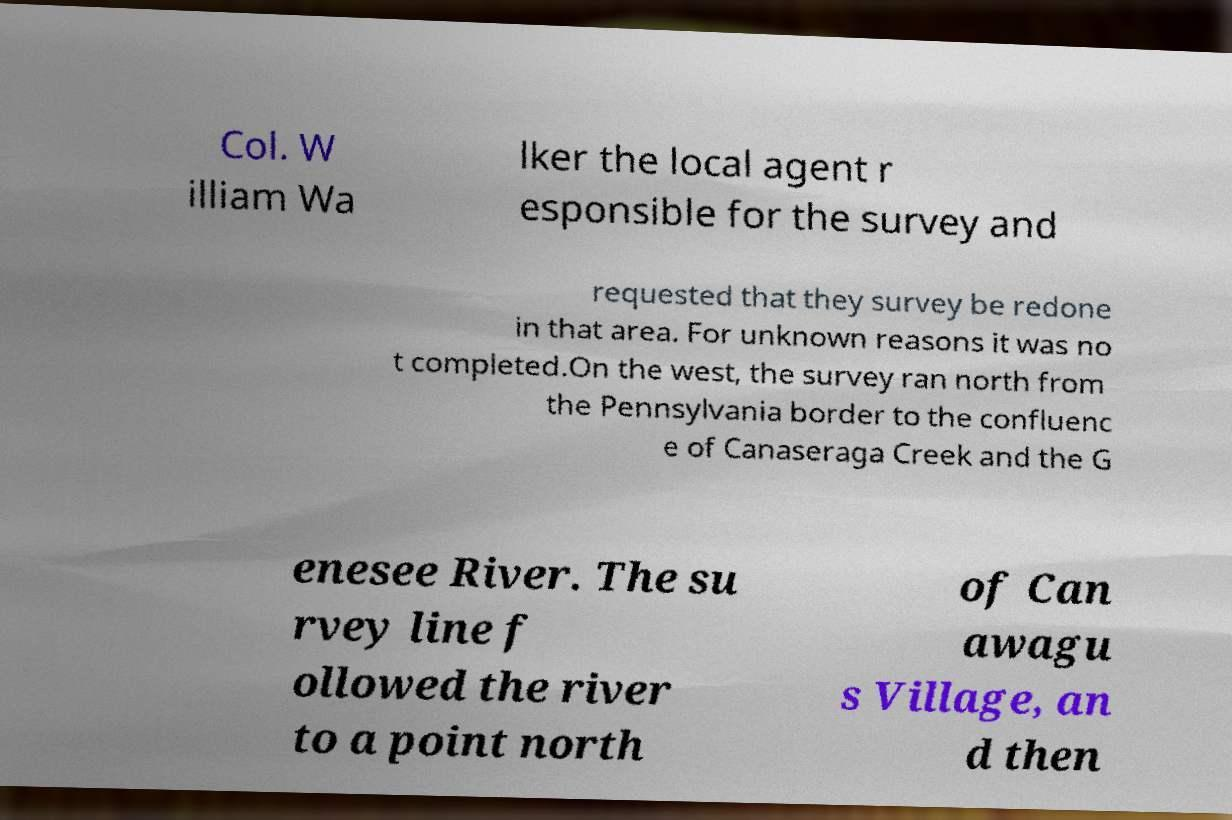Could you assist in decoding the text presented in this image and type it out clearly? Col. W illiam Wa lker the local agent r esponsible for the survey and requested that they survey be redone in that area. For unknown reasons it was no t completed.On the west, the survey ran north from the Pennsylvania border to the confluenc e of Canaseraga Creek and the G enesee River. The su rvey line f ollowed the river to a point north of Can awagu s Village, an d then 